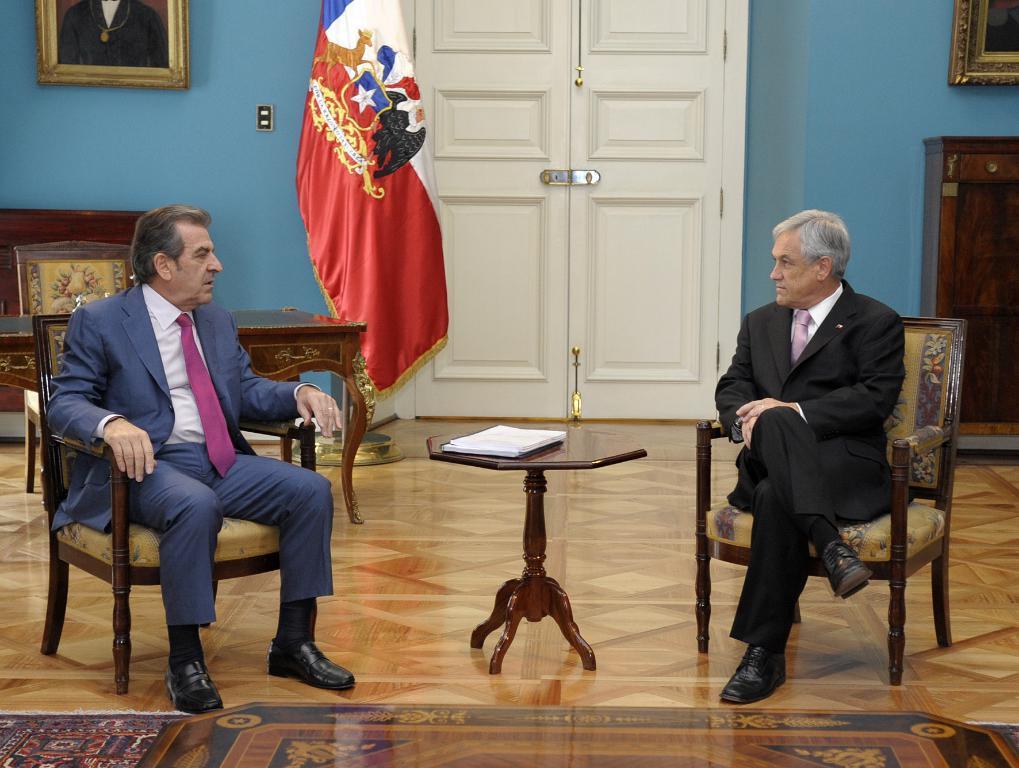Please provide a concise description of this image. There are two men sitting on chairs. There is a table. On the table there are books. In the background there is a door, flag, wall, two photo frames, cupboards and a table. 